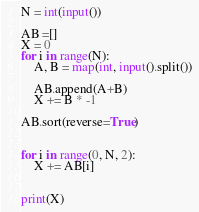Convert code to text. <code><loc_0><loc_0><loc_500><loc_500><_Python_>N = int(input())

AB =[]
X = 0
for i in range(N):
    A, B = map(int, input().split())

    AB.append(A+B)
    X += B * -1

AB.sort(reverse=True)


for i in range(0, N, 2):
    X += AB[i]


print(X)</code> 